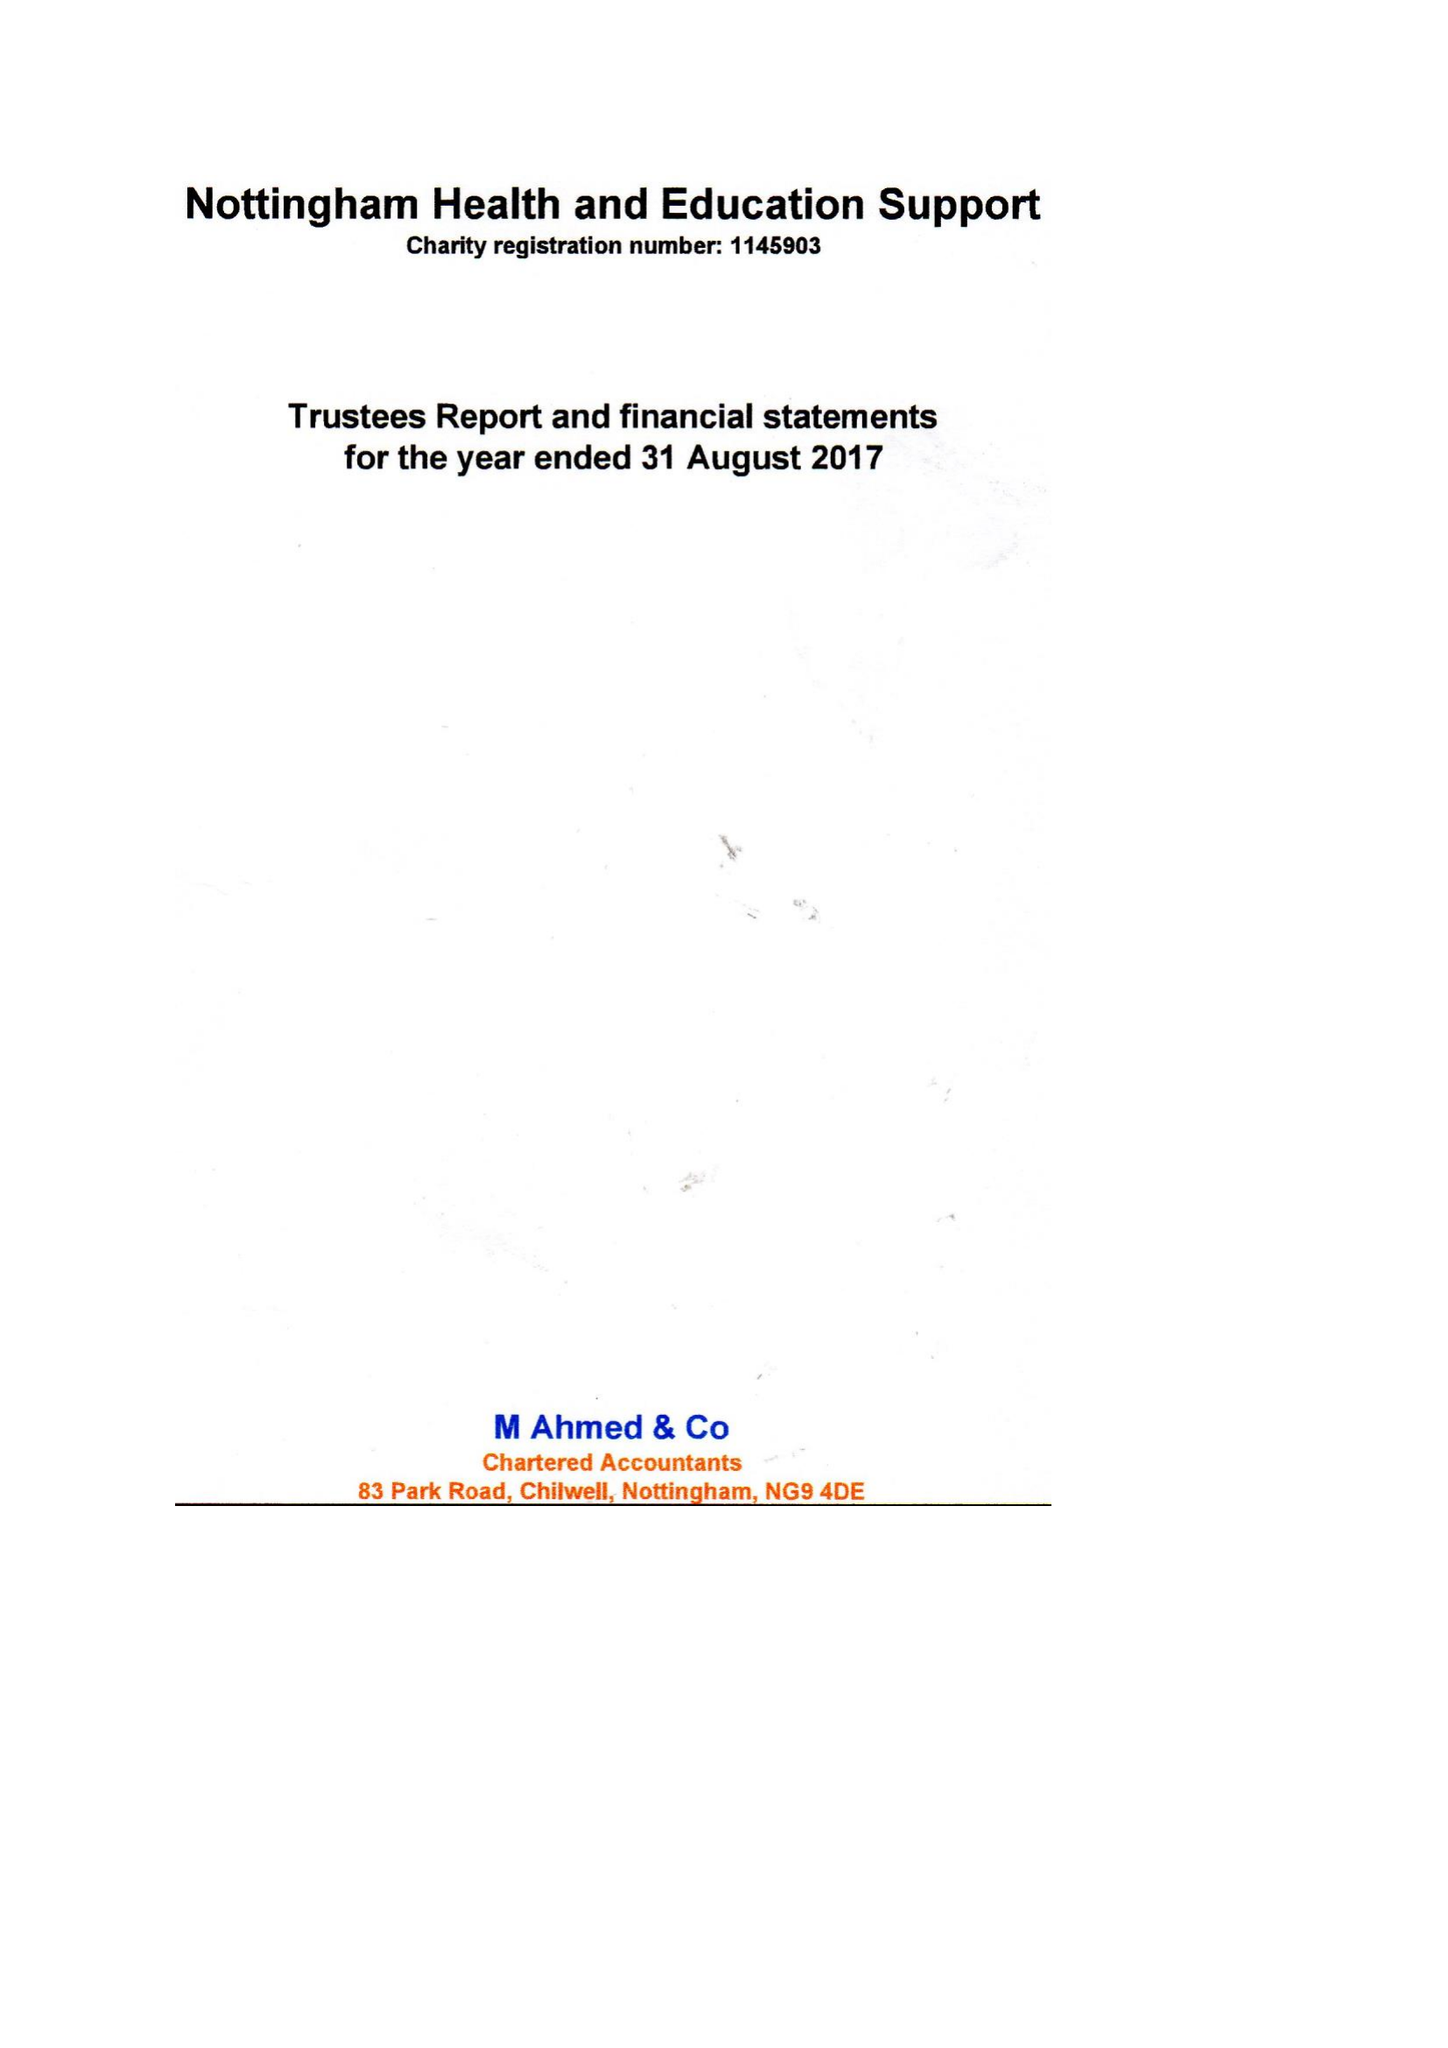What is the value for the address__street_line?
Answer the question using a single word or phrase. 9 CLAYGATE 